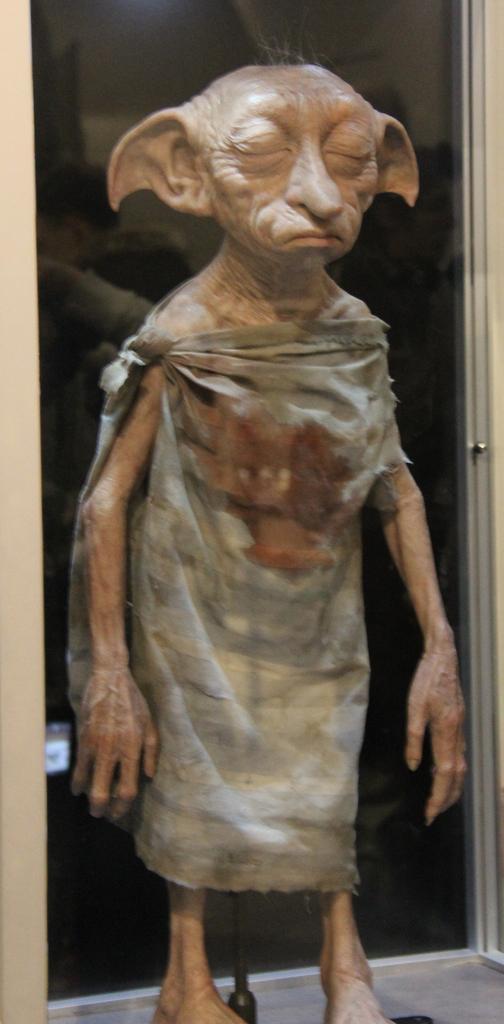How would you summarize this image in a sentence or two? In this picture there is a Warner bros in the center of the image. 